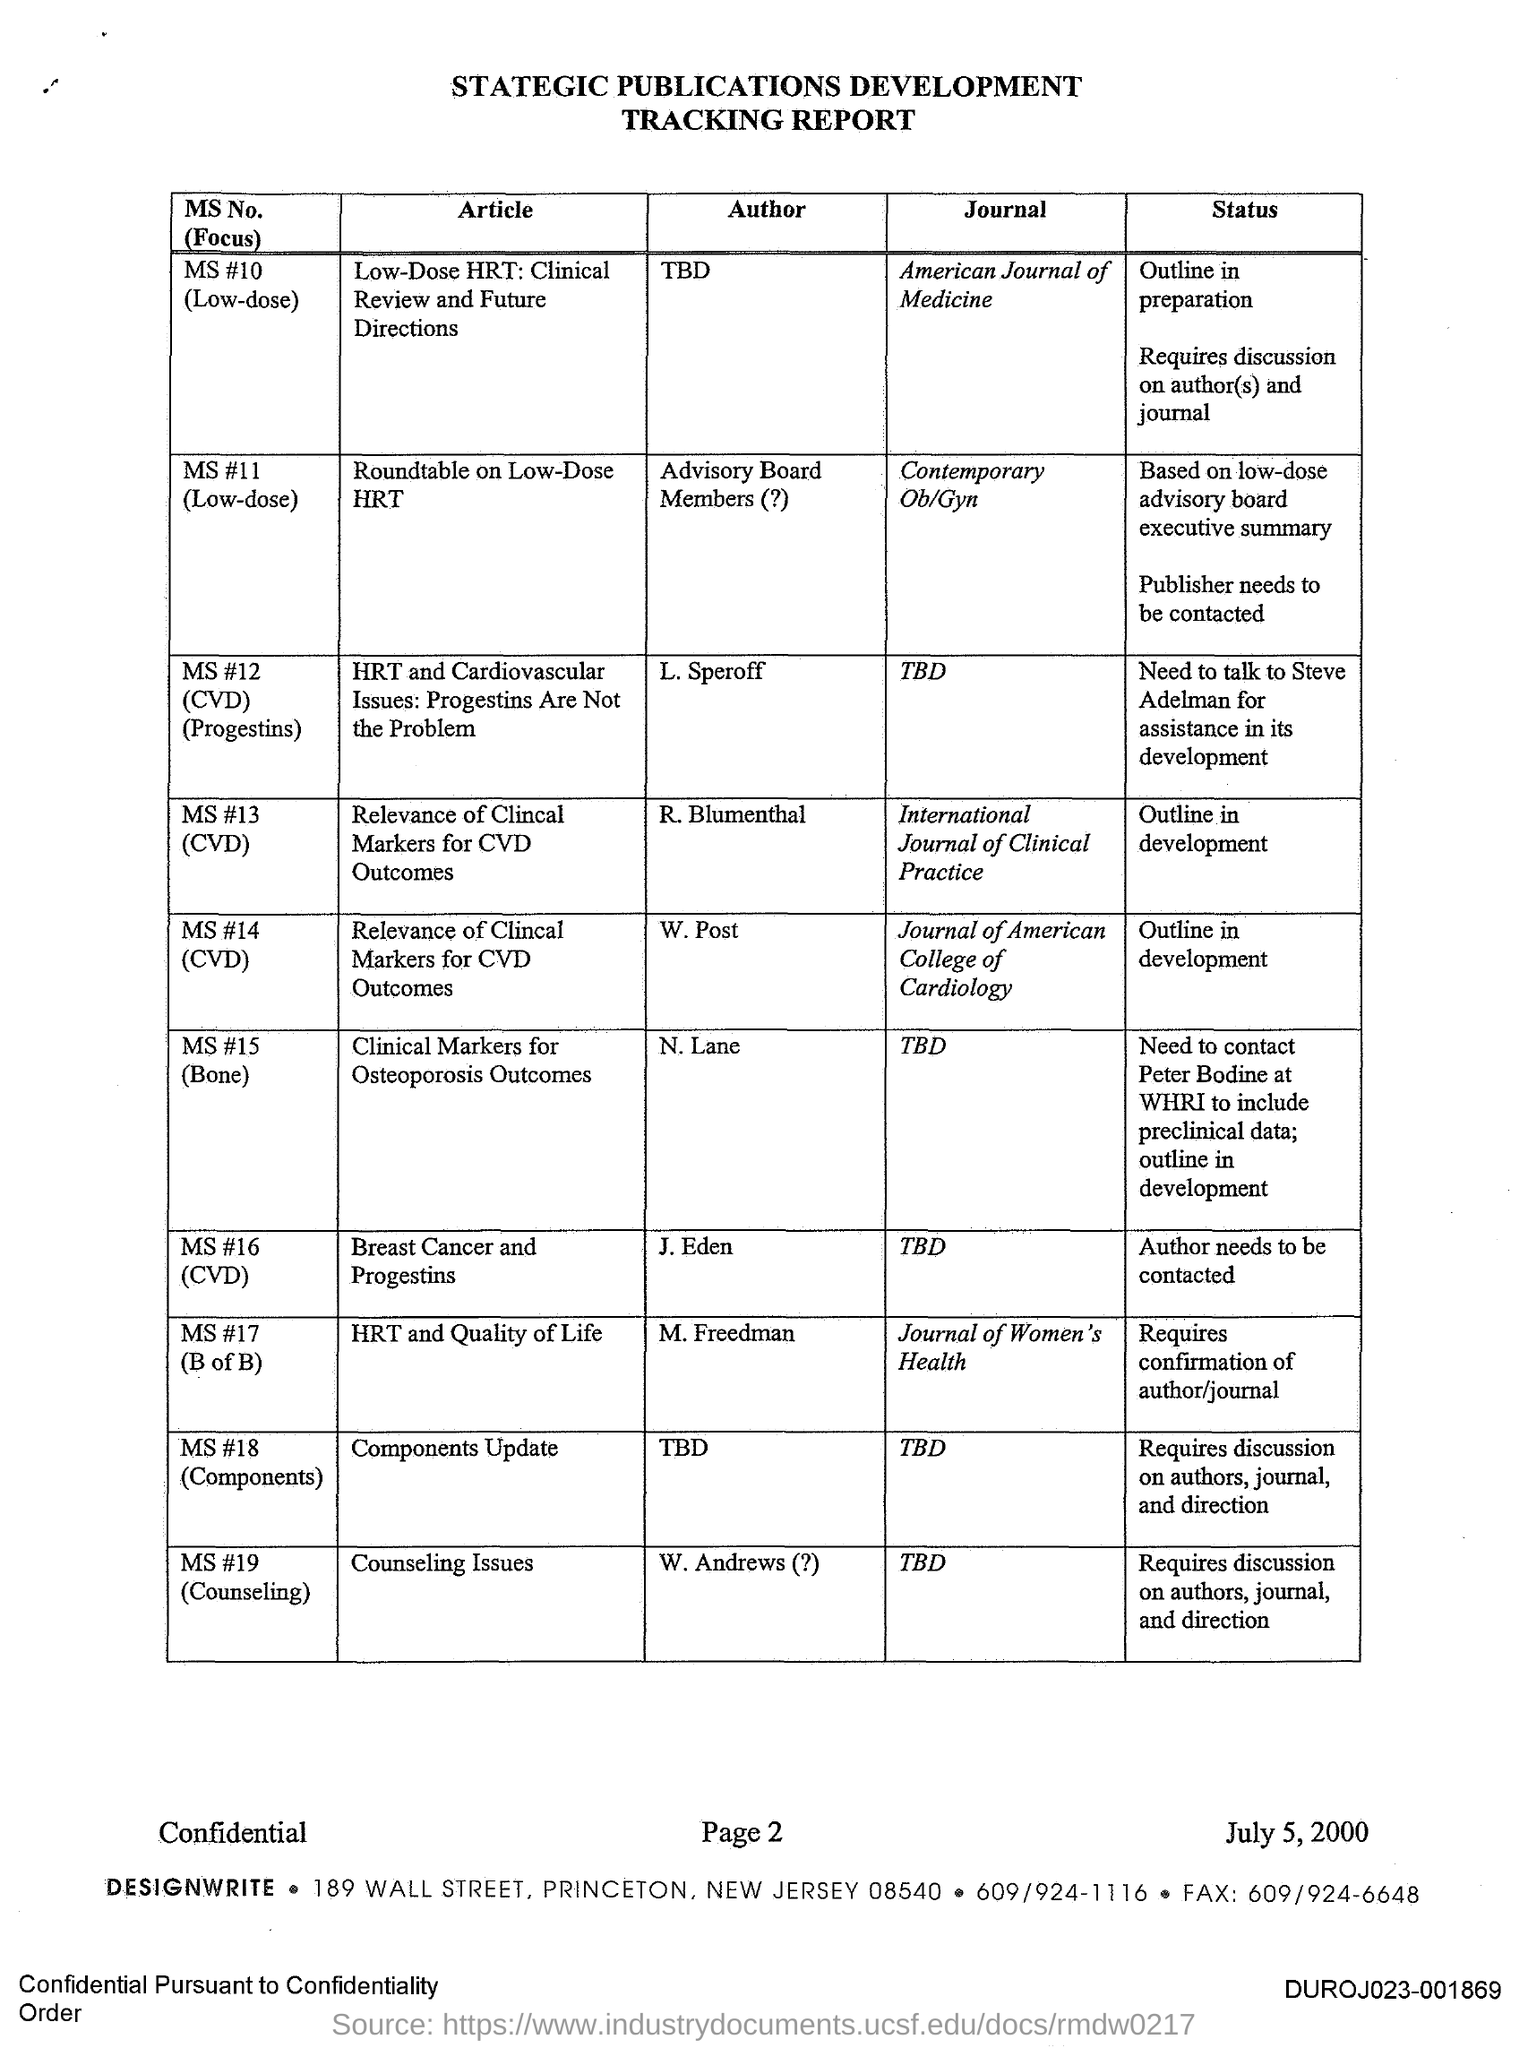In which journal, the article titled 'HRT and Quality of Life' is published? The article titled 'HRT and Quality of Life', authored by M. Freedman, is published in the 'Journal of Women's Health'. This information indicates that the journal focuses on issues and research important to women's health, and that the article's topic is significant enough to warrant inclusion in such a specialized publication. 